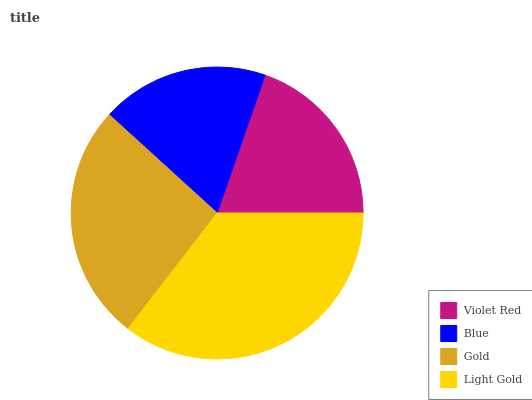Is Blue the minimum?
Answer yes or no. Yes. Is Light Gold the maximum?
Answer yes or no. Yes. Is Gold the minimum?
Answer yes or no. No. Is Gold the maximum?
Answer yes or no. No. Is Gold greater than Blue?
Answer yes or no. Yes. Is Blue less than Gold?
Answer yes or no. Yes. Is Blue greater than Gold?
Answer yes or no. No. Is Gold less than Blue?
Answer yes or no. No. Is Gold the high median?
Answer yes or no. Yes. Is Violet Red the low median?
Answer yes or no. Yes. Is Blue the high median?
Answer yes or no. No. Is Gold the low median?
Answer yes or no. No. 